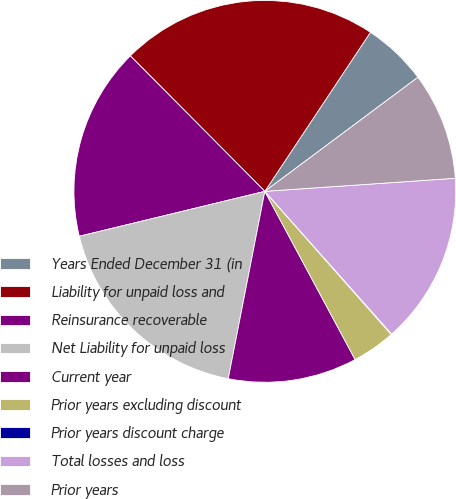<chart> <loc_0><loc_0><loc_500><loc_500><pie_chart><fcel>Years Ended December 31 (in<fcel>Liability for unpaid loss and<fcel>Reinsurance recoverable<fcel>Net Liability for unpaid loss<fcel>Current year<fcel>Prior years excluding discount<fcel>Prior years discount charge<fcel>Total losses and loss<fcel>Prior years<nl><fcel>5.48%<fcel>21.77%<fcel>16.34%<fcel>18.15%<fcel>10.91%<fcel>3.67%<fcel>0.05%<fcel>14.53%<fcel>9.1%<nl></chart> 